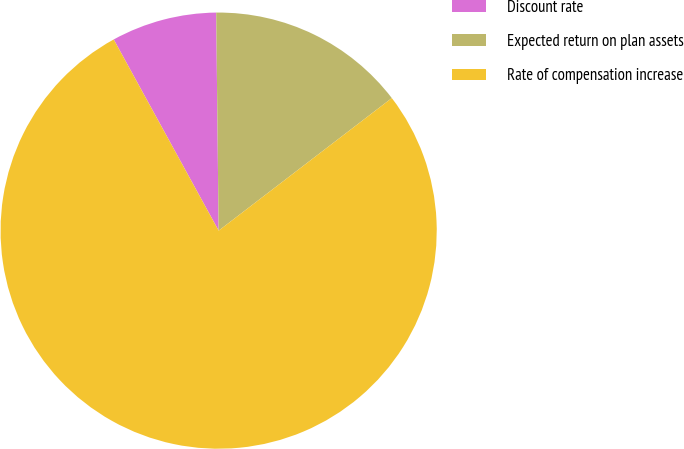Convert chart. <chart><loc_0><loc_0><loc_500><loc_500><pie_chart><fcel>Discount rate<fcel>Expected return on plan assets<fcel>Rate of compensation increase<nl><fcel>7.81%<fcel>14.78%<fcel>77.41%<nl></chart> 